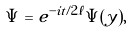Convert formula to latex. <formula><loc_0><loc_0><loc_500><loc_500>\Psi = e ^ { - i t / 2 \ell } \tilde { \Psi } ( y ) ,</formula> 